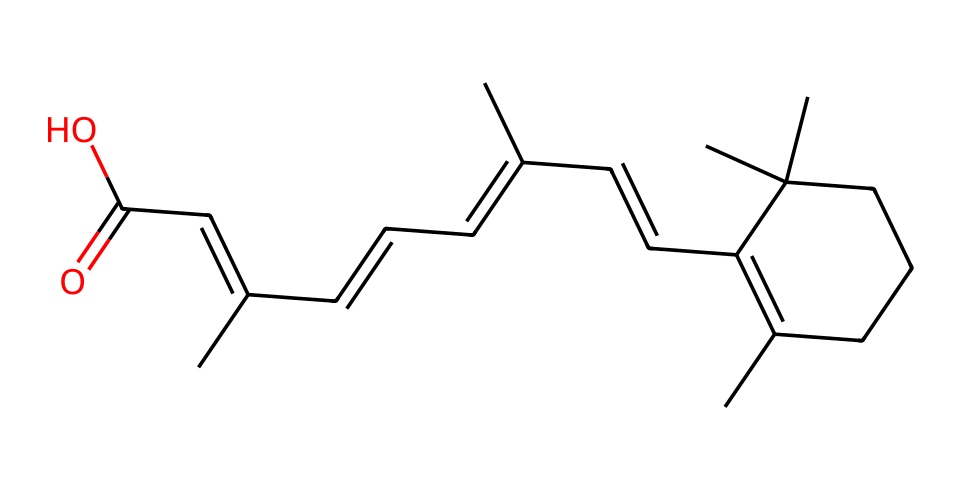What is the common name for this chemical? This chemical is recognized as vitamin A, specifically in its retinol form, which is essential for vision and immune function.
Answer: vitamin A How many carbon atoms are present in the structure? By counting the carbons represented in the SMILES notation, there are a total of 20 carbon atoms present in the structure.
Answer: 20 What functional group is present at the end of the carbon chain? The presence of the -COOH group at the end indicates that this molecule is a carboxylic acid, which is characteristic of some vitamins.
Answer: carboxylic acid How many rings are present in this chemical structure? The structure shows that there is one cyclic component, which can be deduced from the part of the SMILES that forms a loop.
Answer: 1 What type of vitamin is this classified as? This chemical is classified as a fat-soluble vitamin, which plays a crucial role in various bodily functions and must be consumed with dietary fat.
Answer: fat-soluble Which part of the molecule is most critical for its biological activity? The β-ionone ring and the polar end group are vital for the biological activity of vitamin A, directly influencing its role in vision.
Answer: β-ionone ring 